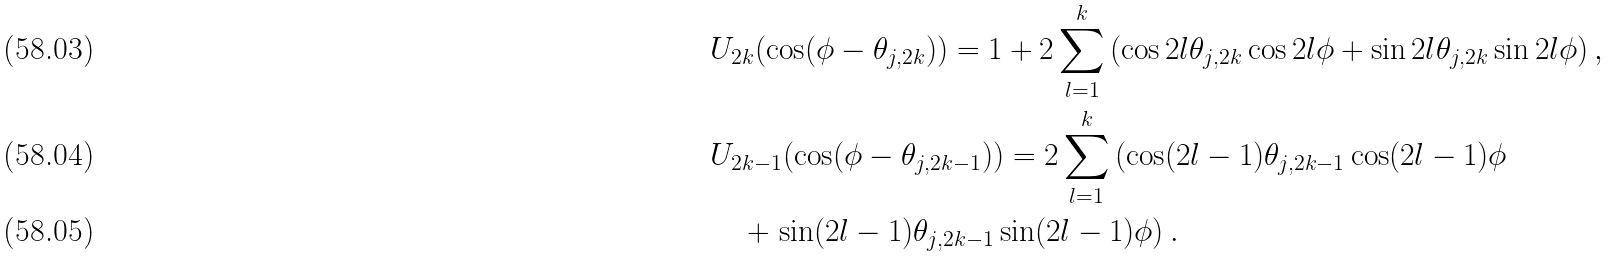Convert formula to latex. <formula><loc_0><loc_0><loc_500><loc_500>& U _ { 2 k } ( \cos ( \phi - \theta _ { j , 2 k } ) ) = 1 + 2 \sum _ { l = 1 } ^ { k } \left ( \cos 2 l \theta _ { j , 2 k } \cos 2 l \phi + \sin 2 l \theta _ { j , 2 k } \sin 2 l \phi \right ) , \\ & U _ { 2 k - 1 } ( \cos ( \phi - \theta _ { j , 2 k - 1 } ) ) = 2 \sum _ { l = 1 } ^ { k } \left ( \cos ( 2 l - 1 ) \theta _ { j , 2 k - 1 } \cos ( 2 l - 1 ) \phi \right . \\ & \quad + \left . \sin ( 2 l - 1 ) \theta _ { j , 2 k - 1 } \sin ( 2 l - 1 ) \phi \right ) .</formula> 